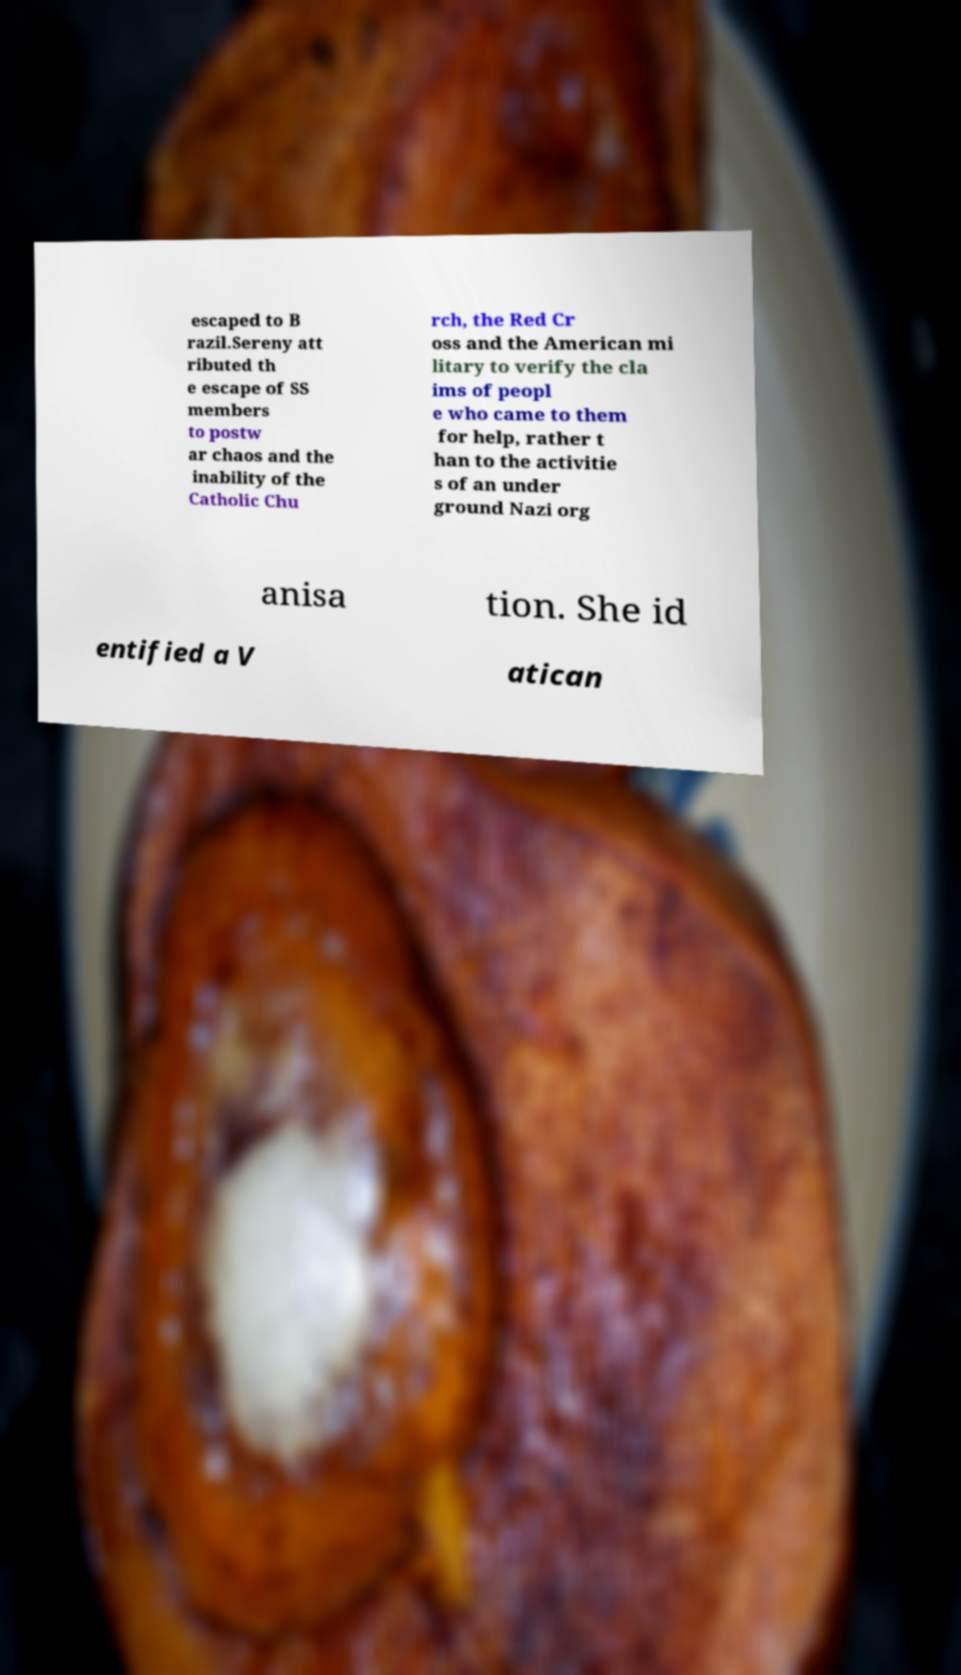What messages or text are displayed in this image? I need them in a readable, typed format. escaped to B razil.Sereny att ributed th e escape of SS members to postw ar chaos and the inability of the Catholic Chu rch, the Red Cr oss and the American mi litary to verify the cla ims of peopl e who came to them for help, rather t han to the activitie s of an under ground Nazi org anisa tion. She id entified a V atican 